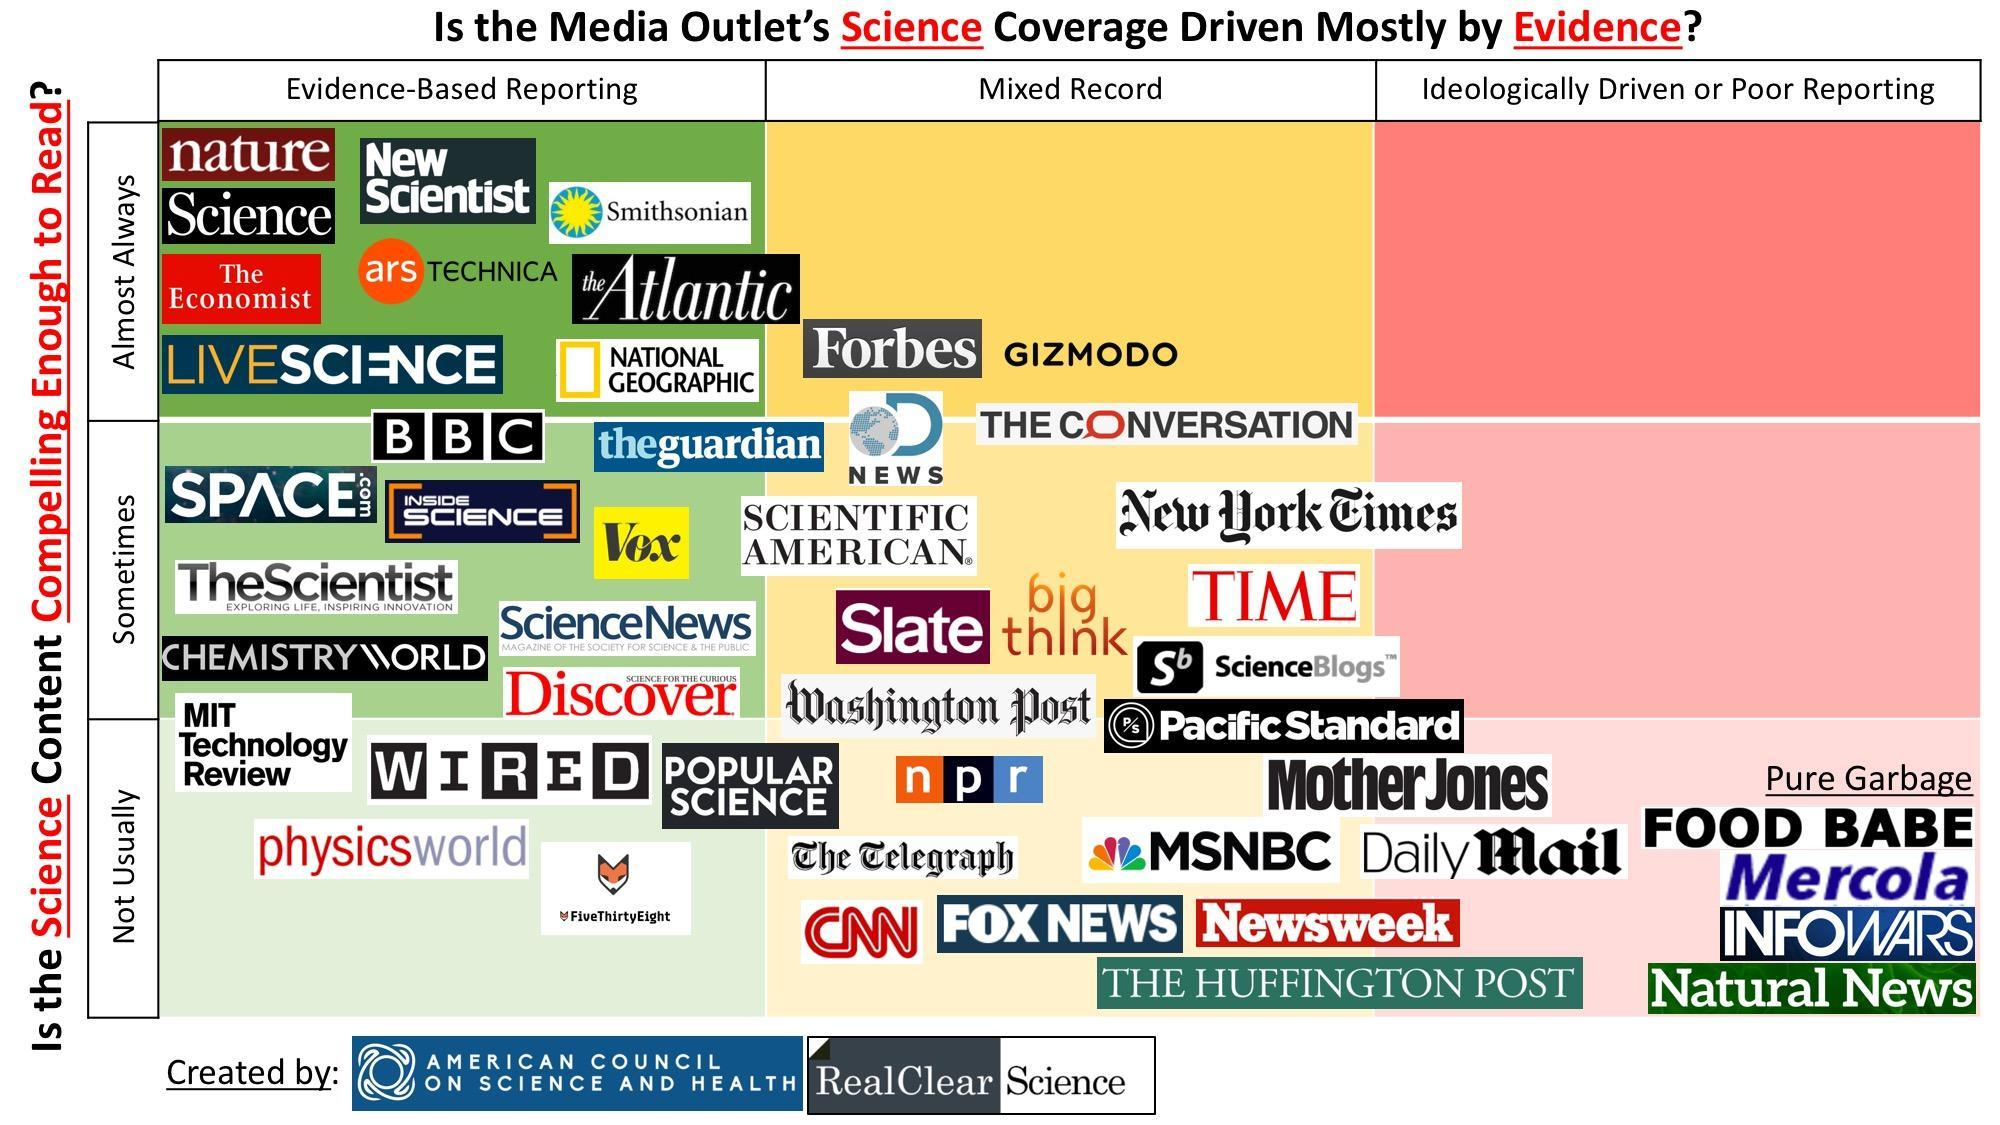How many media outlets have poor reporting almost always
Answer the question with a short phrase. 0 How often does big think have a mixed record of reporting sometimes What sort of reporting does new scientist almost always have Evidence-based reporting What sort of reporting does vox have and how often Evidence-based reporting, sometimes What sort of reporting does Slate have mixed record 